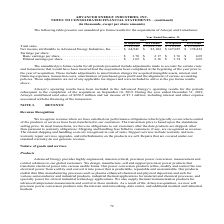According to Advanced Energy's financial document, What did the unaudited pro forma results for all periods presented include? adjustments made to account for certain costs and transactions that would have been incurred had the acquisitions been completed at the beginning of the year prior to the year of acquisition.. The document states: "ro forma results for all periods presented include adjustments made to account for certain costs and transactions that would have been incurred had th..." Also, What was the total sales as reported in 2019? According to the financial document, $788,948 (in thousands). The relevant text states: "Total sales . $ 788,948 $ 1,202,790 $ 718,892 $ 1,350,037 Net income attributable to Advanced Energy Industries, Inc. . $ 6..." Also, What does the table show? unaudited pro forma results for the acquisitions of Artesyn and LumaSense. The document states: "The following table presents our unaudited pro forma results for the acquisitions of Artesyn and LumaSense:..." Also, can you calculate: What was the change in Pro Forma total sales between 2018 and 2019? Based on the calculation: $1,202,790-$1,350,037, the result is -147247 (in thousands). This is based on the information: "Total sales . $ 788,948 $ 1,202,790 $ 718,892 $ 1,350,037 Net income attributable to Advanced Energy Industries, Inc. . $ 64,941 $ 83,104 $ 147,025 $ 158,422 Total sales . $ 788,948 $ 1,202,790 $ 718,..." The key data points involved are: 1,202,790, 1,350,037. Also, can you calculate: What was the change in basic earnings per share as reported between 2018 and 2019? Based on the calculation: $1.70-$3.76, the result is -2.06. This is based on the information: "Earnings per share: Basic earnings per share . $ 1.70 $ 2.17 $ 3.76 $ 4.05 Diluted earnings per share . $ 1.69 $ 2.16 $ 3.74 $ 4.03 share: Basic earnings per share . $ 1.70 $ 2.17 $ 3.76 $ 4.05 Dilute..." The key data points involved are: 1.70, 3.76. Also, can you calculate: What was the percentage change in Net income attributable to Advanced Energy Industries, Inc. as reported between 2018 and 2019 To answer this question, I need to perform calculations using the financial data. The calculation is: ($64,941-$147,025)/$147,025, which equals -55.83 (percentage). This is based on the information: "ced Energy Industries, Inc. . $ 64,941 $ 83,104 $ 147,025 $ 158,422 Earnings per share: Basic earnings per share . $ 1.70 $ 2.17 $ 3.76 $ 4.05 Diluted earnin ributable to Advanced Energy Industries, I..." The key data points involved are: 147,025, 64,941. 